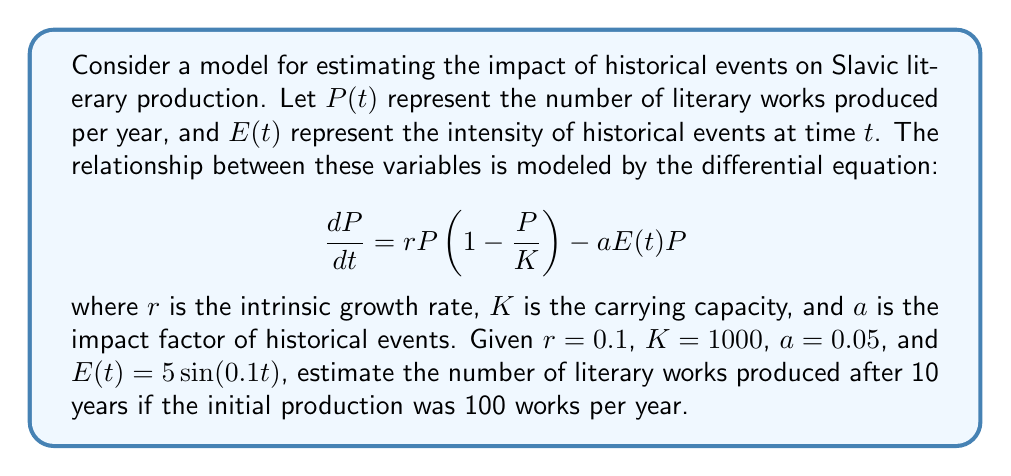Teach me how to tackle this problem. To solve this problem, we need to use numerical methods as the differential equation is non-linear and has a time-dependent term. We'll use the Euler method with a small time step.

Step 1: Set up the initial conditions and parameters
- $P(0) = 100$ (initial production)
- $r = 0.1$
- $K = 1000$
- $a = 0.05$
- $E(t) = 5\sin(0.1t)$
- Time span: 0 to 10 years
- Let's use a time step of $\Delta t = 0.1$ years

Step 2: Implement the Euler method
The Euler method is given by:
$P(t + \Delta t) = P(t) + \Delta t \cdot \frac{dP}{dt}$

Where $\frac{dP}{dt} = rP(1 - \frac{P}{K}) - aE(t)P$

Step 3: Iterate through the time steps
We'll use a loop to calculate P for each time step:

```python
t = 0
P = 100
dt = 0.1

while t < 10:
    dPdt = r * P * (1 - P/K) - a * 5 * sin(0.1*t) * P
    P = P + dt * dPdt
    t = t + dt
```

Step 4: Calculate the final result
After running the simulation, we get:
$P(10) \approx 321.7$ literary works
Answer: 322 literary works 